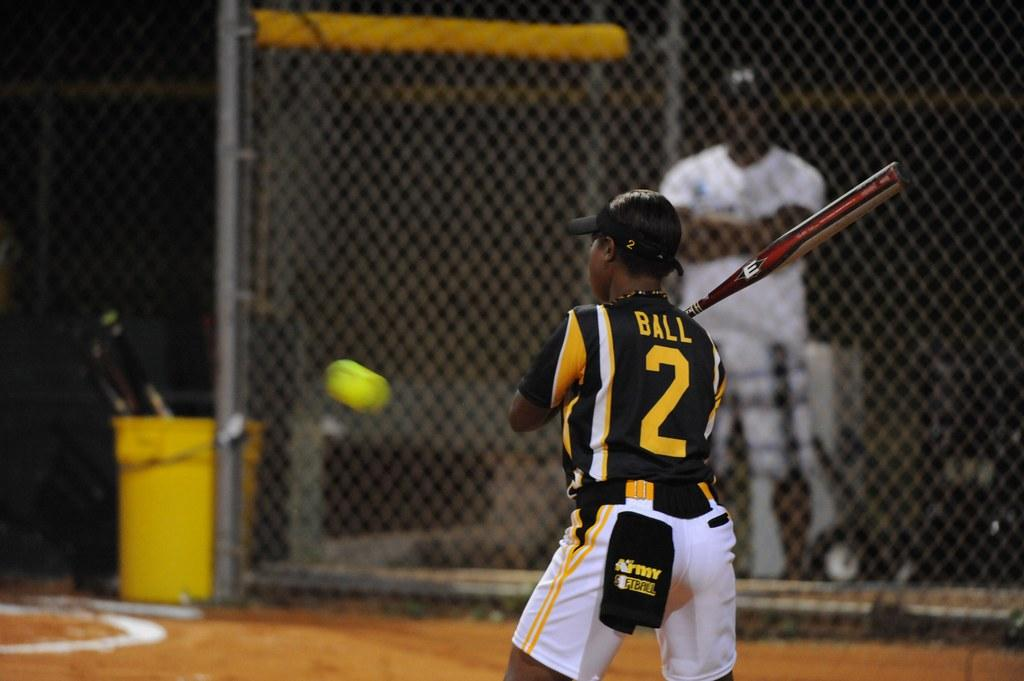Provide a one-sentence caption for the provided image. A batter named Ball playing in a baseball game. 